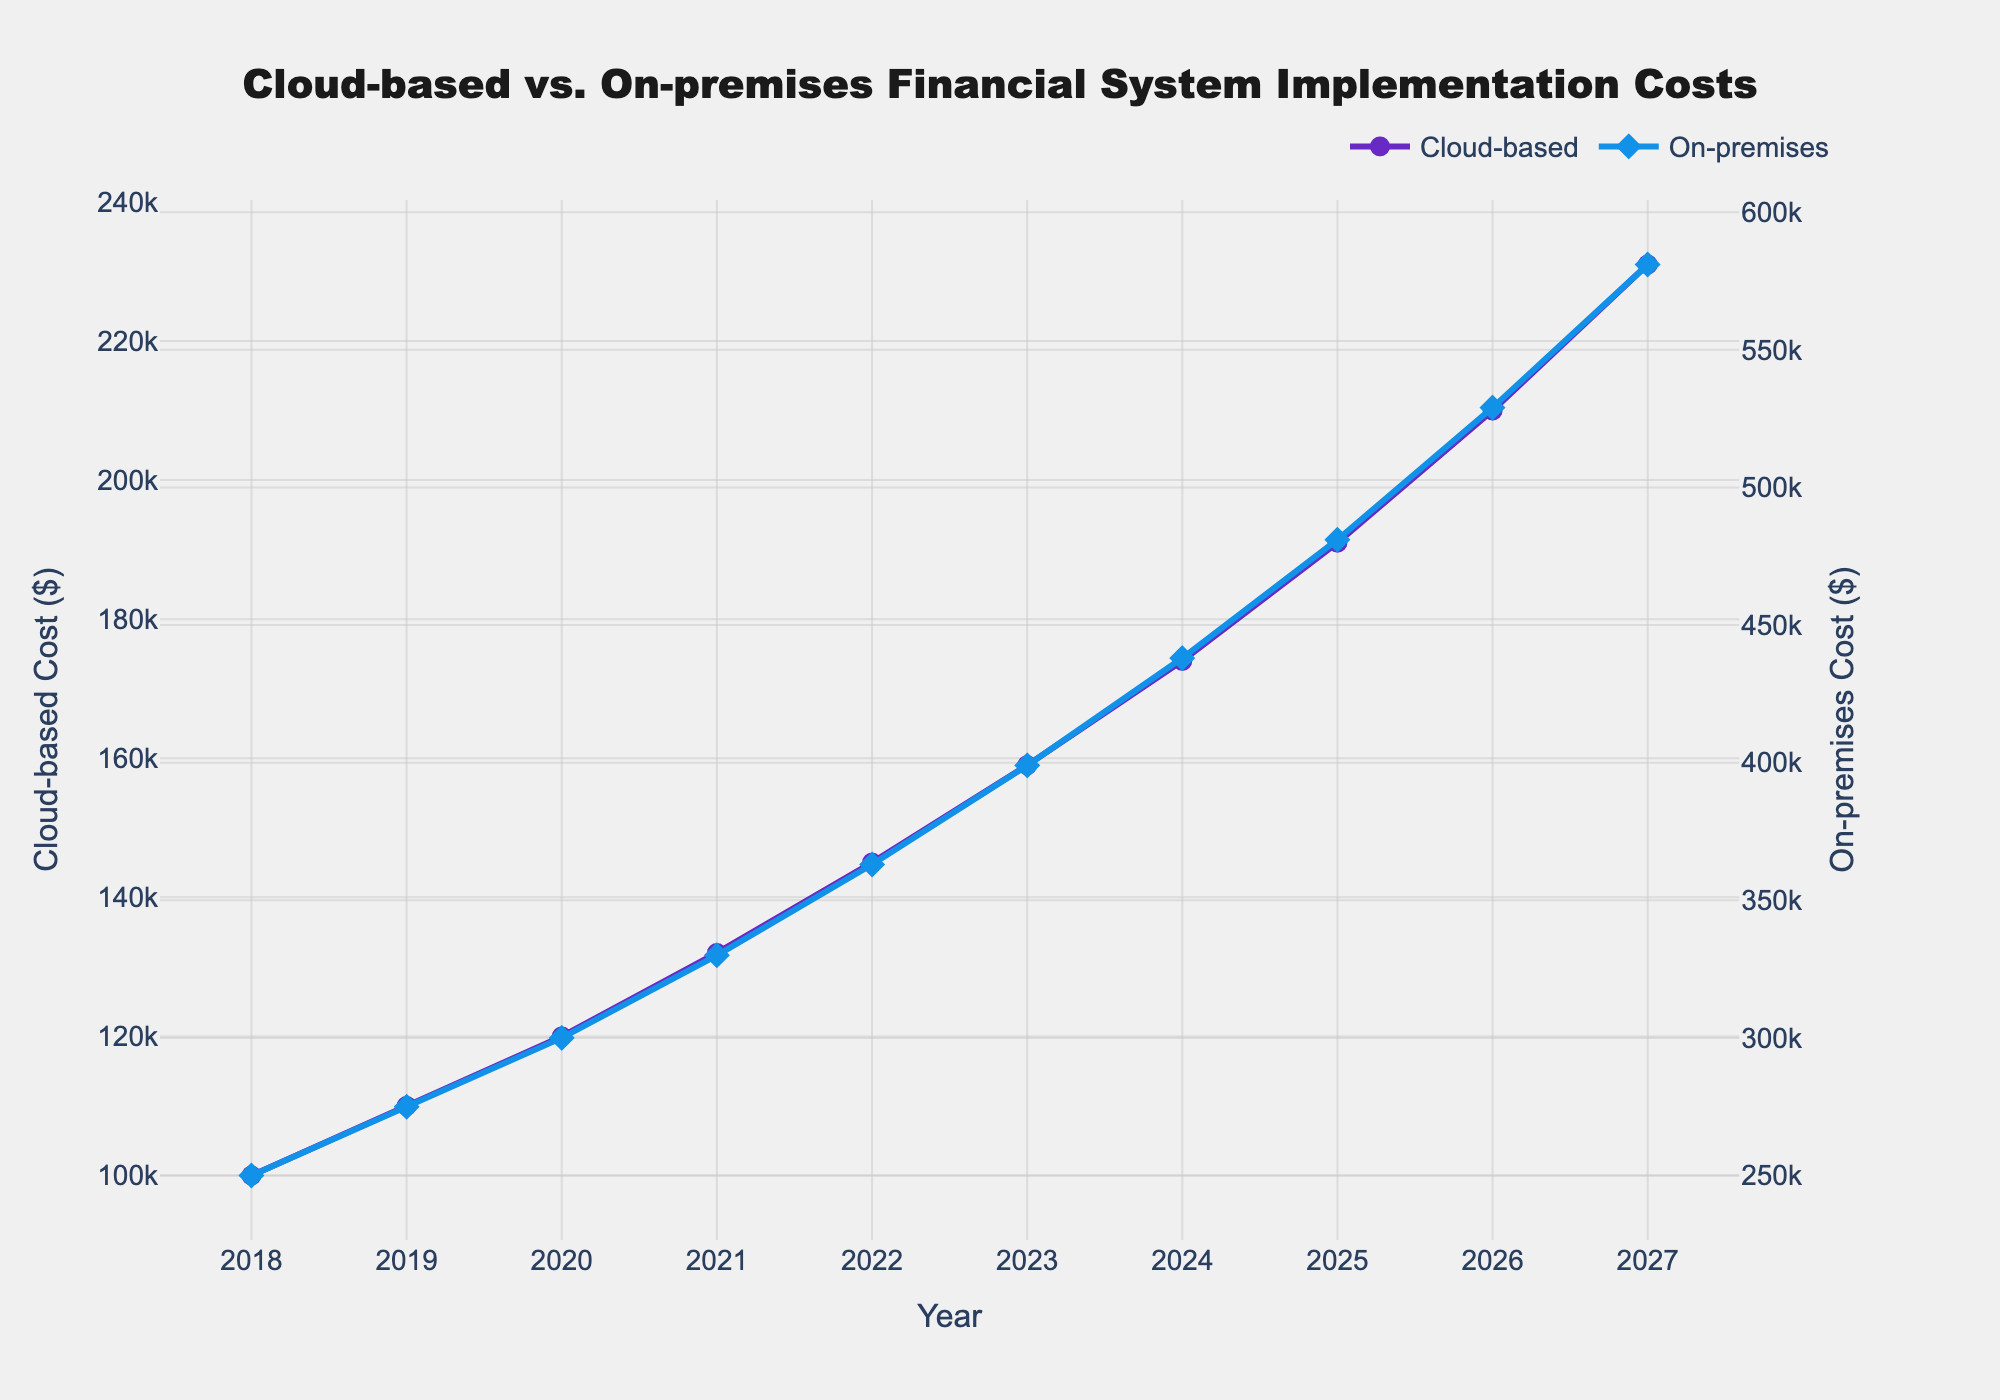What is the cost of implementing the cloud-based system in 2023? Refer to the figure and look at the data point for the cloud-based system in 2023. The value is shown as $159,000.
Answer: $159,000 Which year sees the highest implementation cost for the on-premises system? Check the plot for on-premises system costs across all years and identify the highest point. The maximum cost occurs in 2027 at $581,000.
Answer: 2027 By how much did the cost of the cloud-based system increase from 2018 to 2027? Subtract the 2018 implementation cost from the 2027 implementation cost for the cloud-based system. $231,000 (in 2027) minus $100,000 (in 2018) equals $131,000 increase.
Answer: $131,000 In 2020, which system had a lower implementation cost, and what was the difference? Compare the costs of the two systems for 2020. The cloud-based system cost is $120,000 and the on-premises system cost is $300,000. The difference is $300,000 - $120,000 = $180,000.
Answer: Cloud-based, $180,000 What is the average cost of the on-premises system over the 10-year period? Sum the implementation costs for on-premises system from 2018 to 2027 and divide by 10. The sum is $250,000 + $275,000 + $300,000 + $330,000 + $363,000 + $399,000 + $438,000 + $481,000 + $529,000 + $581,000 = $3,946,000. The average is $3,946,000 / 10 = $394,600.
Answer: $394,600 By what percentage did the cost of the cloud-based system increase from 2019 to 2020? Calculate the percentage increase by subtracting the 2019 cost from the 2020 cost, then dividing by the 2019 cost and multiplying by 100. $(120,000 - 110,000) / 110,000 \times 100 = 9.09\%$.
Answer: 9.09% During which year did both systems see approximately equal increments in their cost compared to the previous year? Compare each year's cost increase to the previous year for both cloud-based and on-premises systems and find a year where the increments are similar. Both systems increased by similar amounts between 2019 and 2020. For cloud-based, $120,000 - $110,000 = $10,000$. For on-premises, $300,000 - $275,000 = $25,000$. Both are proportionally similar.
Answer: 2020 Which line has a steeper upward trend visually, representing faster cost increase, and what does it represent? The on-premises system's line is steeper compared to the cloud-based system's line, indicating a faster rate of cost increase.
Answer: On-premises system 